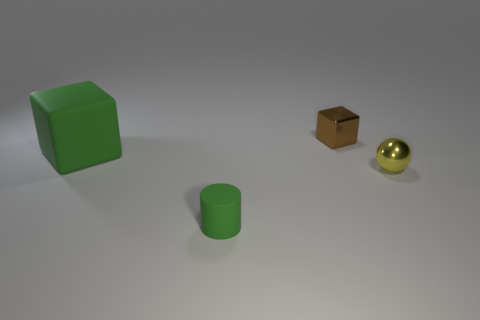What number of other things are there of the same color as the small ball?
Ensure brevity in your answer.  0. What number of cyan objects are either large objects or rubber things?
Your answer should be compact. 0. What material is the small object that is behind the small sphere?
Provide a succinct answer. Metal. Is the material of the block on the right side of the tiny rubber object the same as the yellow object?
Your response must be concise. Yes. What is the shape of the tiny brown metallic thing?
Make the answer very short. Cube. How many green matte objects are behind the tiny brown shiny object that is to the left of the metal thing that is in front of the big green thing?
Provide a succinct answer. 0. What material is the ball that is the same size as the matte cylinder?
Keep it short and to the point. Metal. Do the matte object that is behind the small cylinder and the matte object that is to the right of the matte cube have the same color?
Keep it short and to the point. Yes. Is there a green object of the same shape as the small brown metallic object?
Make the answer very short. Yes. What shape is the matte thing that is the same size as the yellow metal object?
Provide a succinct answer. Cylinder. 